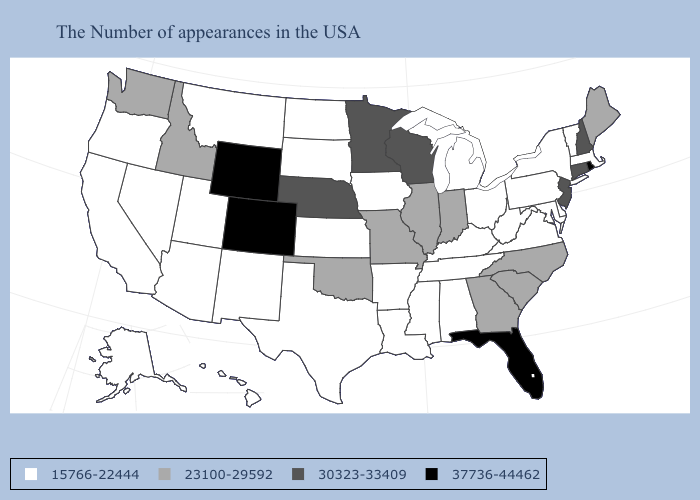What is the value of North Carolina?
Keep it brief. 23100-29592. What is the highest value in the South ?
Concise answer only. 37736-44462. What is the highest value in the USA?
Be succinct. 37736-44462. Name the states that have a value in the range 37736-44462?
Quick response, please. Rhode Island, Florida, Wyoming, Colorado. Which states hav the highest value in the West?
Short answer required. Wyoming, Colorado. What is the value of Wyoming?
Answer briefly. 37736-44462. Does Missouri have the lowest value in the MidWest?
Answer briefly. No. Does Rhode Island have the lowest value in the Northeast?
Concise answer only. No. Name the states that have a value in the range 37736-44462?
Concise answer only. Rhode Island, Florida, Wyoming, Colorado. Does the first symbol in the legend represent the smallest category?
Write a very short answer. Yes. Among the states that border Massachusetts , which have the lowest value?
Give a very brief answer. Vermont, New York. Name the states that have a value in the range 23100-29592?
Concise answer only. Maine, North Carolina, South Carolina, Georgia, Indiana, Illinois, Missouri, Oklahoma, Idaho, Washington. What is the lowest value in the USA?
Short answer required. 15766-22444. What is the value of Utah?
Be succinct. 15766-22444. Among the states that border Maine , which have the highest value?
Write a very short answer. New Hampshire. 